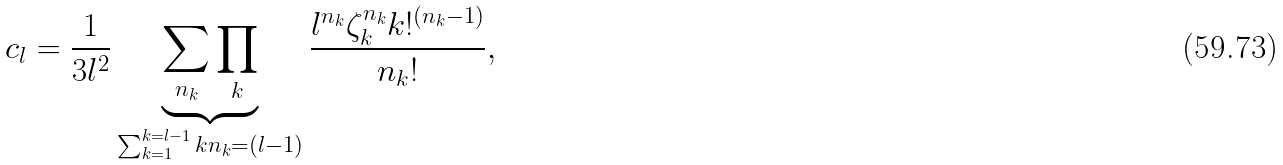Convert formula to latex. <formula><loc_0><loc_0><loc_500><loc_500>c _ { l } = \frac { 1 } { 3 l ^ { 2 } } \underbrace { \sum _ { n _ { k } } \prod _ { k } } _ { \sum _ { k = 1 } ^ { k = l - 1 } k n _ { k } = ( l - 1 ) } \frac { l ^ { n _ { k } } \zeta _ { k } ^ { n _ { k } } k ! ^ { ( n _ { k } - 1 ) } } { n _ { k } ! } ,</formula> 